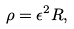Convert formula to latex. <formula><loc_0><loc_0><loc_500><loc_500>\rho & = \epsilon ^ { 2 } R ,</formula> 